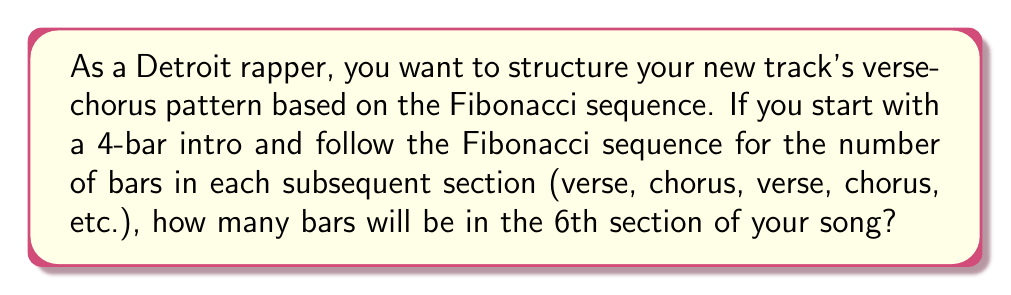Could you help me with this problem? Let's approach this step-by-step:

1) First, recall the Fibonacci sequence: 
   $$F_n = F_{n-1} + F_{n-2}$$
   where $F_1 = 1$, $F_2 = 1$

2) In this case, we're starting with a 4-bar intro, so our sequence will be shifted. Let's call the intro $F_0 = 4$.

3) Now, let's calculate the number of bars for each section:

   Section 1 (Intro): $F_0 = 4$ bars
   Section 2 (1st Verse): $F_1 = 1$ bar
   Section 3 (1st Chorus): $F_2 = 1$ bar
   Section 4 (2nd Verse): $F_3 = F_2 + F_1 = 1 + 1 = 2$ bars
   Section 5 (2nd Chorus): $F_4 = F_3 + F_2 = 2 + 1 = 3$ bars
   Section 6 (3rd Verse): $F_5 = F_4 + F_3 = 3 + 2 = 5$ bars

4) Therefore, the 6th section of the song (which would be the 3rd verse) will have 5 bars.

This structure creates an interesting progression in your song, with sections gradually increasing in length, potentially building tension and complexity as the track progresses.
Answer: 5 bars 